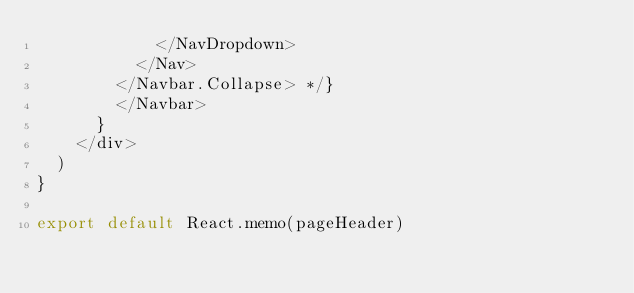<code> <loc_0><loc_0><loc_500><loc_500><_JavaScript_>            </NavDropdown>
          </Nav>
        </Navbar.Collapse> */}
        </Navbar>
      }
    </div>
  )
}

export default React.memo(pageHeader)
</code> 